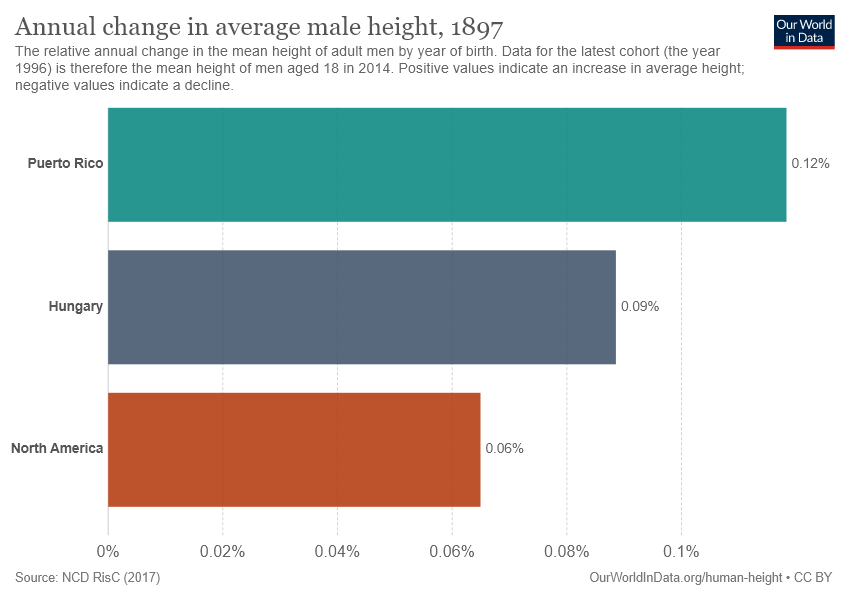Mention a couple of crucial points in this snapshot. We need to determine the ratio of the longest bar to the shortest bar, which is approximately 0.084027778... The annual change in male height in North America was 0.36, and in Hungary, the square root of that was 0. 